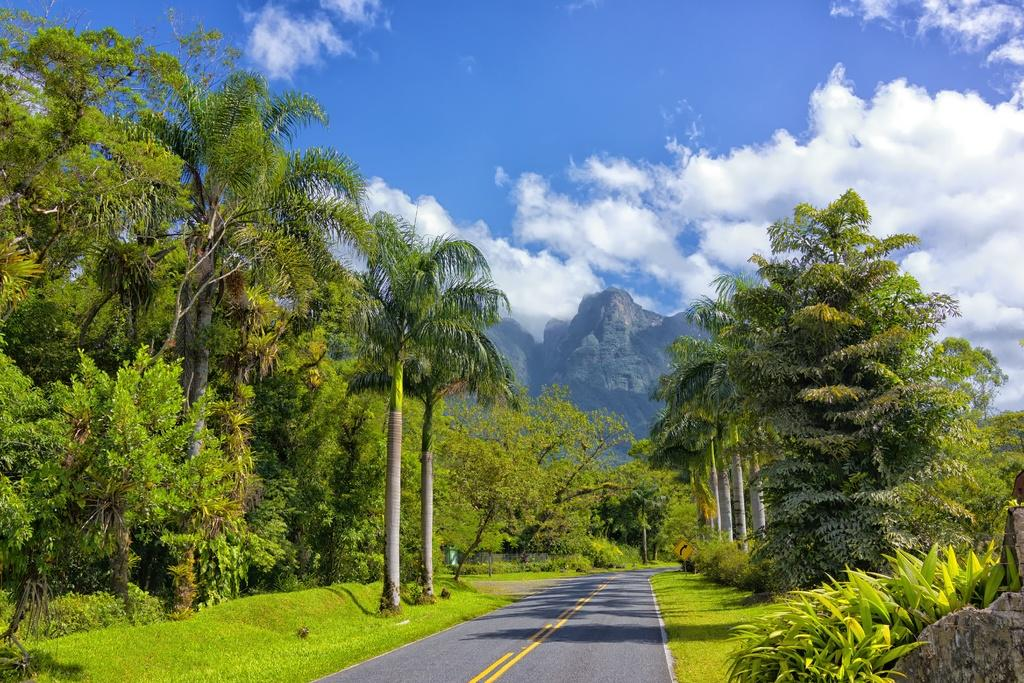What is the main feature in the middle of the image? There is a road at the center of the image. What can be seen on both sides of the road? Trees are present on either side of the road. What is visible in the distance behind the trees? There are mountains in the background of the image. What is visible above the mountains in the image? The sky is visible in the background of the image. What type of prose is being recited by the trees in the image? There is no indication in the image that the trees are reciting any prose. 